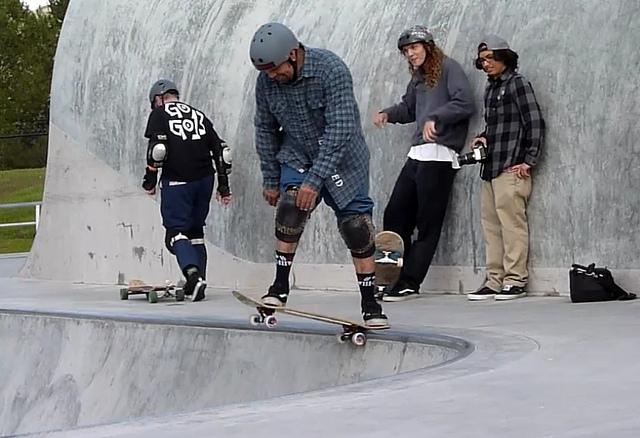Besides his head what part of his body is the skateboarder on the edge of the ramp protecting? knees 